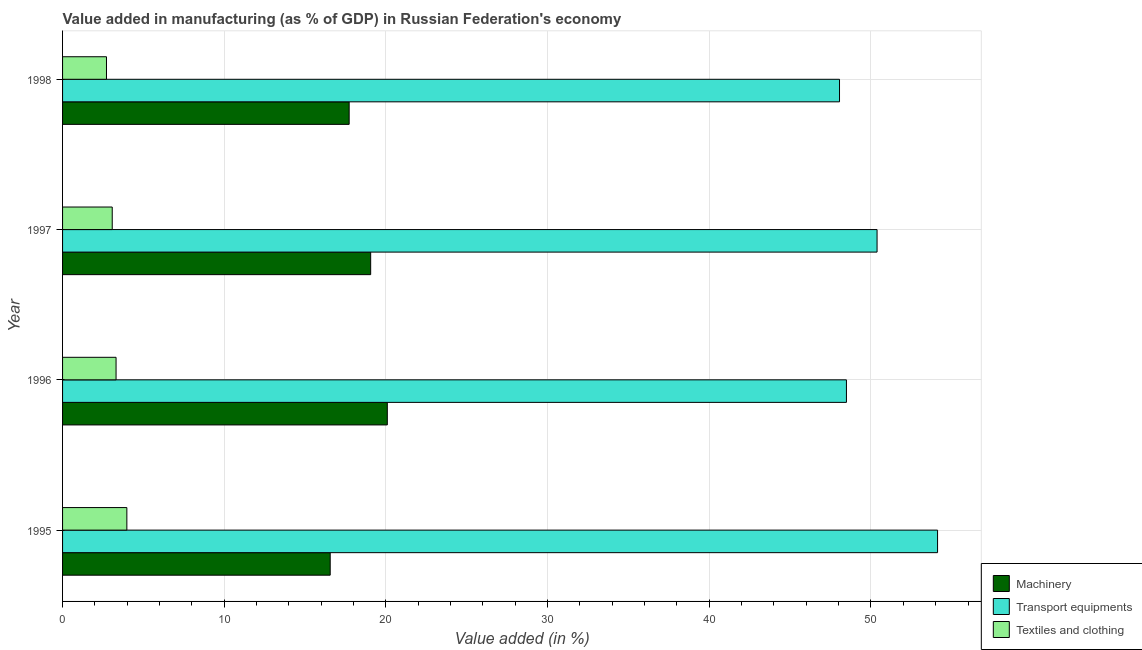How many different coloured bars are there?
Your answer should be compact. 3. Are the number of bars per tick equal to the number of legend labels?
Keep it short and to the point. Yes. Are the number of bars on each tick of the Y-axis equal?
Keep it short and to the point. Yes. How many bars are there on the 3rd tick from the top?
Your answer should be compact. 3. What is the label of the 4th group of bars from the top?
Give a very brief answer. 1995. In how many cases, is the number of bars for a given year not equal to the number of legend labels?
Make the answer very short. 0. What is the value added in manufacturing machinery in 1997?
Ensure brevity in your answer.  19.06. Across all years, what is the maximum value added in manufacturing machinery?
Ensure brevity in your answer.  20.09. Across all years, what is the minimum value added in manufacturing transport equipments?
Give a very brief answer. 48.05. In which year was the value added in manufacturing textile and clothing minimum?
Provide a succinct answer. 1998. What is the total value added in manufacturing transport equipments in the graph?
Your response must be concise. 201.03. What is the difference between the value added in manufacturing textile and clothing in 1996 and that in 1998?
Your answer should be compact. 0.59. What is the difference between the value added in manufacturing textile and clothing in 1997 and the value added in manufacturing transport equipments in 1998?
Your answer should be compact. -44.98. What is the average value added in manufacturing textile and clothing per year?
Ensure brevity in your answer.  3.27. In the year 1996, what is the difference between the value added in manufacturing machinery and value added in manufacturing transport equipments?
Your response must be concise. -28.4. In how many years, is the value added in manufacturing transport equipments greater than 2 %?
Offer a terse response. 4. What is the ratio of the value added in manufacturing textile and clothing in 1995 to that in 1997?
Give a very brief answer. 1.29. What is the difference between the highest and the second highest value added in manufacturing transport equipments?
Offer a very short reply. 3.74. What is the difference between the highest and the lowest value added in manufacturing machinery?
Offer a terse response. 3.53. Is the sum of the value added in manufacturing textile and clothing in 1995 and 1996 greater than the maximum value added in manufacturing transport equipments across all years?
Ensure brevity in your answer.  No. What does the 1st bar from the top in 1996 represents?
Make the answer very short. Textiles and clothing. What does the 1st bar from the bottom in 1996 represents?
Offer a very short reply. Machinery. Is it the case that in every year, the sum of the value added in manufacturing machinery and value added in manufacturing transport equipments is greater than the value added in manufacturing textile and clothing?
Make the answer very short. Yes. How many bars are there?
Offer a terse response. 12. Are all the bars in the graph horizontal?
Make the answer very short. Yes. How many years are there in the graph?
Give a very brief answer. 4. What is the difference between two consecutive major ticks on the X-axis?
Offer a terse response. 10. Are the values on the major ticks of X-axis written in scientific E-notation?
Offer a very short reply. No. Where does the legend appear in the graph?
Provide a succinct answer. Bottom right. What is the title of the graph?
Offer a terse response. Value added in manufacturing (as % of GDP) in Russian Federation's economy. What is the label or title of the X-axis?
Offer a very short reply. Value added (in %). What is the label or title of the Y-axis?
Offer a very short reply. Year. What is the Value added (in %) of Machinery in 1995?
Your answer should be compact. 16.55. What is the Value added (in %) of Transport equipments in 1995?
Keep it short and to the point. 54.12. What is the Value added (in %) of Textiles and clothing in 1995?
Offer a very short reply. 3.98. What is the Value added (in %) in Machinery in 1996?
Provide a short and direct response. 20.09. What is the Value added (in %) of Transport equipments in 1996?
Your answer should be very brief. 48.48. What is the Value added (in %) of Textiles and clothing in 1996?
Give a very brief answer. 3.31. What is the Value added (in %) of Machinery in 1997?
Your response must be concise. 19.06. What is the Value added (in %) of Transport equipments in 1997?
Keep it short and to the point. 50.38. What is the Value added (in %) in Textiles and clothing in 1997?
Make the answer very short. 3.07. What is the Value added (in %) of Machinery in 1998?
Offer a very short reply. 17.73. What is the Value added (in %) in Transport equipments in 1998?
Provide a succinct answer. 48.05. What is the Value added (in %) in Textiles and clothing in 1998?
Keep it short and to the point. 2.72. Across all years, what is the maximum Value added (in %) in Machinery?
Provide a succinct answer. 20.09. Across all years, what is the maximum Value added (in %) in Transport equipments?
Give a very brief answer. 54.12. Across all years, what is the maximum Value added (in %) in Textiles and clothing?
Ensure brevity in your answer.  3.98. Across all years, what is the minimum Value added (in %) in Machinery?
Provide a short and direct response. 16.55. Across all years, what is the minimum Value added (in %) of Transport equipments?
Make the answer very short. 48.05. Across all years, what is the minimum Value added (in %) of Textiles and clothing?
Offer a very short reply. 2.72. What is the total Value added (in %) of Machinery in the graph?
Ensure brevity in your answer.  73.42. What is the total Value added (in %) of Transport equipments in the graph?
Ensure brevity in your answer.  201.03. What is the total Value added (in %) in Textiles and clothing in the graph?
Offer a terse response. 13.07. What is the difference between the Value added (in %) of Machinery in 1995 and that in 1996?
Your answer should be very brief. -3.53. What is the difference between the Value added (in %) of Transport equipments in 1995 and that in 1996?
Your answer should be compact. 5.64. What is the difference between the Value added (in %) in Textiles and clothing in 1995 and that in 1996?
Provide a succinct answer. 0.67. What is the difference between the Value added (in %) of Machinery in 1995 and that in 1997?
Keep it short and to the point. -2.5. What is the difference between the Value added (in %) in Transport equipments in 1995 and that in 1997?
Offer a terse response. 3.74. What is the difference between the Value added (in %) in Textiles and clothing in 1995 and that in 1997?
Give a very brief answer. 0.9. What is the difference between the Value added (in %) in Machinery in 1995 and that in 1998?
Your answer should be compact. -1.17. What is the difference between the Value added (in %) of Transport equipments in 1995 and that in 1998?
Your response must be concise. 6.06. What is the difference between the Value added (in %) of Textiles and clothing in 1995 and that in 1998?
Your answer should be very brief. 1.26. What is the difference between the Value added (in %) in Machinery in 1996 and that in 1997?
Give a very brief answer. 1.03. What is the difference between the Value added (in %) in Transport equipments in 1996 and that in 1997?
Make the answer very short. -1.89. What is the difference between the Value added (in %) of Textiles and clothing in 1996 and that in 1997?
Your response must be concise. 0.24. What is the difference between the Value added (in %) of Machinery in 1996 and that in 1998?
Your response must be concise. 2.36. What is the difference between the Value added (in %) in Transport equipments in 1996 and that in 1998?
Make the answer very short. 0.43. What is the difference between the Value added (in %) of Textiles and clothing in 1996 and that in 1998?
Provide a short and direct response. 0.59. What is the difference between the Value added (in %) in Machinery in 1997 and that in 1998?
Offer a terse response. 1.33. What is the difference between the Value added (in %) in Transport equipments in 1997 and that in 1998?
Offer a terse response. 2.32. What is the difference between the Value added (in %) of Textiles and clothing in 1997 and that in 1998?
Provide a succinct answer. 0.36. What is the difference between the Value added (in %) of Machinery in 1995 and the Value added (in %) of Transport equipments in 1996?
Provide a short and direct response. -31.93. What is the difference between the Value added (in %) in Machinery in 1995 and the Value added (in %) in Textiles and clothing in 1996?
Offer a terse response. 13.24. What is the difference between the Value added (in %) of Transport equipments in 1995 and the Value added (in %) of Textiles and clothing in 1996?
Your answer should be very brief. 50.81. What is the difference between the Value added (in %) of Machinery in 1995 and the Value added (in %) of Transport equipments in 1997?
Give a very brief answer. -33.82. What is the difference between the Value added (in %) of Machinery in 1995 and the Value added (in %) of Textiles and clothing in 1997?
Keep it short and to the point. 13.48. What is the difference between the Value added (in %) of Transport equipments in 1995 and the Value added (in %) of Textiles and clothing in 1997?
Provide a short and direct response. 51.05. What is the difference between the Value added (in %) in Machinery in 1995 and the Value added (in %) in Transport equipments in 1998?
Make the answer very short. -31.5. What is the difference between the Value added (in %) of Machinery in 1995 and the Value added (in %) of Textiles and clothing in 1998?
Ensure brevity in your answer.  13.84. What is the difference between the Value added (in %) in Transport equipments in 1995 and the Value added (in %) in Textiles and clothing in 1998?
Ensure brevity in your answer.  51.4. What is the difference between the Value added (in %) of Machinery in 1996 and the Value added (in %) of Transport equipments in 1997?
Your answer should be compact. -30.29. What is the difference between the Value added (in %) in Machinery in 1996 and the Value added (in %) in Textiles and clothing in 1997?
Provide a short and direct response. 17.01. What is the difference between the Value added (in %) in Transport equipments in 1996 and the Value added (in %) in Textiles and clothing in 1997?
Ensure brevity in your answer.  45.41. What is the difference between the Value added (in %) in Machinery in 1996 and the Value added (in %) in Transport equipments in 1998?
Ensure brevity in your answer.  -27.97. What is the difference between the Value added (in %) of Machinery in 1996 and the Value added (in %) of Textiles and clothing in 1998?
Make the answer very short. 17.37. What is the difference between the Value added (in %) of Transport equipments in 1996 and the Value added (in %) of Textiles and clothing in 1998?
Your response must be concise. 45.77. What is the difference between the Value added (in %) of Machinery in 1997 and the Value added (in %) of Transport equipments in 1998?
Offer a very short reply. -29. What is the difference between the Value added (in %) in Machinery in 1997 and the Value added (in %) in Textiles and clothing in 1998?
Give a very brief answer. 16.34. What is the difference between the Value added (in %) of Transport equipments in 1997 and the Value added (in %) of Textiles and clothing in 1998?
Provide a short and direct response. 47.66. What is the average Value added (in %) in Machinery per year?
Your answer should be very brief. 18.35. What is the average Value added (in %) in Transport equipments per year?
Your answer should be compact. 50.26. What is the average Value added (in %) in Textiles and clothing per year?
Ensure brevity in your answer.  3.27. In the year 1995, what is the difference between the Value added (in %) in Machinery and Value added (in %) in Transport equipments?
Make the answer very short. -37.56. In the year 1995, what is the difference between the Value added (in %) of Machinery and Value added (in %) of Textiles and clothing?
Make the answer very short. 12.58. In the year 1995, what is the difference between the Value added (in %) in Transport equipments and Value added (in %) in Textiles and clothing?
Offer a terse response. 50.14. In the year 1996, what is the difference between the Value added (in %) in Machinery and Value added (in %) in Transport equipments?
Your answer should be compact. -28.4. In the year 1996, what is the difference between the Value added (in %) of Machinery and Value added (in %) of Textiles and clothing?
Provide a short and direct response. 16.78. In the year 1996, what is the difference between the Value added (in %) of Transport equipments and Value added (in %) of Textiles and clothing?
Your answer should be very brief. 45.17. In the year 1997, what is the difference between the Value added (in %) of Machinery and Value added (in %) of Transport equipments?
Provide a succinct answer. -31.32. In the year 1997, what is the difference between the Value added (in %) in Machinery and Value added (in %) in Textiles and clothing?
Offer a terse response. 15.98. In the year 1997, what is the difference between the Value added (in %) in Transport equipments and Value added (in %) in Textiles and clothing?
Provide a succinct answer. 47.3. In the year 1998, what is the difference between the Value added (in %) in Machinery and Value added (in %) in Transport equipments?
Ensure brevity in your answer.  -30.33. In the year 1998, what is the difference between the Value added (in %) in Machinery and Value added (in %) in Textiles and clothing?
Your answer should be compact. 15.01. In the year 1998, what is the difference between the Value added (in %) in Transport equipments and Value added (in %) in Textiles and clothing?
Provide a short and direct response. 45.34. What is the ratio of the Value added (in %) of Machinery in 1995 to that in 1996?
Give a very brief answer. 0.82. What is the ratio of the Value added (in %) in Transport equipments in 1995 to that in 1996?
Ensure brevity in your answer.  1.12. What is the ratio of the Value added (in %) in Textiles and clothing in 1995 to that in 1996?
Provide a succinct answer. 1.2. What is the ratio of the Value added (in %) of Machinery in 1995 to that in 1997?
Provide a short and direct response. 0.87. What is the ratio of the Value added (in %) of Transport equipments in 1995 to that in 1997?
Your response must be concise. 1.07. What is the ratio of the Value added (in %) of Textiles and clothing in 1995 to that in 1997?
Provide a short and direct response. 1.29. What is the ratio of the Value added (in %) in Machinery in 1995 to that in 1998?
Make the answer very short. 0.93. What is the ratio of the Value added (in %) of Transport equipments in 1995 to that in 1998?
Ensure brevity in your answer.  1.13. What is the ratio of the Value added (in %) in Textiles and clothing in 1995 to that in 1998?
Keep it short and to the point. 1.46. What is the ratio of the Value added (in %) of Machinery in 1996 to that in 1997?
Your answer should be compact. 1.05. What is the ratio of the Value added (in %) in Transport equipments in 1996 to that in 1997?
Offer a very short reply. 0.96. What is the ratio of the Value added (in %) in Textiles and clothing in 1996 to that in 1997?
Ensure brevity in your answer.  1.08. What is the ratio of the Value added (in %) of Machinery in 1996 to that in 1998?
Keep it short and to the point. 1.13. What is the ratio of the Value added (in %) in Transport equipments in 1996 to that in 1998?
Offer a very short reply. 1.01. What is the ratio of the Value added (in %) of Textiles and clothing in 1996 to that in 1998?
Keep it short and to the point. 1.22. What is the ratio of the Value added (in %) in Machinery in 1997 to that in 1998?
Keep it short and to the point. 1.07. What is the ratio of the Value added (in %) of Transport equipments in 1997 to that in 1998?
Provide a succinct answer. 1.05. What is the ratio of the Value added (in %) of Textiles and clothing in 1997 to that in 1998?
Make the answer very short. 1.13. What is the difference between the highest and the second highest Value added (in %) in Machinery?
Offer a very short reply. 1.03. What is the difference between the highest and the second highest Value added (in %) in Transport equipments?
Provide a succinct answer. 3.74. What is the difference between the highest and the second highest Value added (in %) of Textiles and clothing?
Provide a short and direct response. 0.67. What is the difference between the highest and the lowest Value added (in %) of Machinery?
Your answer should be compact. 3.53. What is the difference between the highest and the lowest Value added (in %) in Transport equipments?
Ensure brevity in your answer.  6.06. What is the difference between the highest and the lowest Value added (in %) of Textiles and clothing?
Your response must be concise. 1.26. 